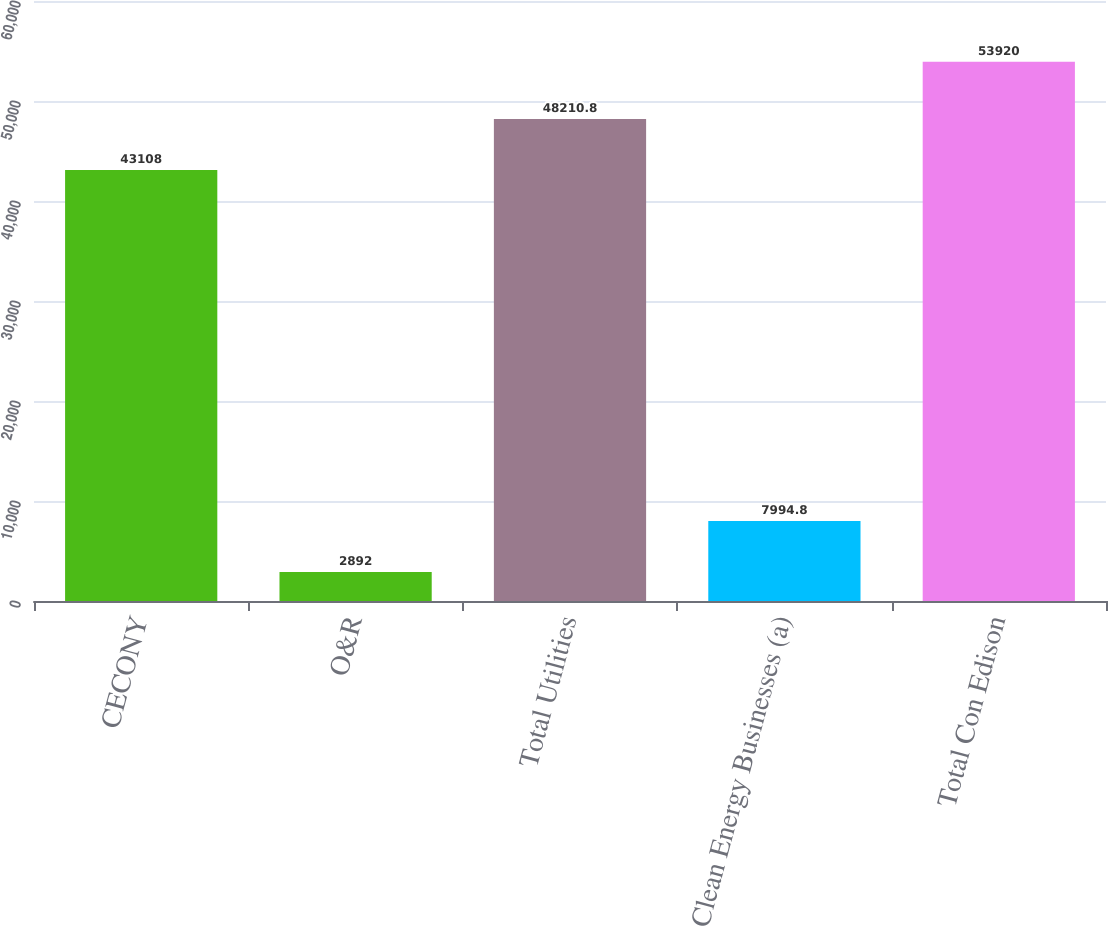Convert chart to OTSL. <chart><loc_0><loc_0><loc_500><loc_500><bar_chart><fcel>CECONY<fcel>O&R<fcel>Total Utilities<fcel>Clean Energy Businesses (a)<fcel>Total Con Edison<nl><fcel>43108<fcel>2892<fcel>48210.8<fcel>7994.8<fcel>53920<nl></chart> 